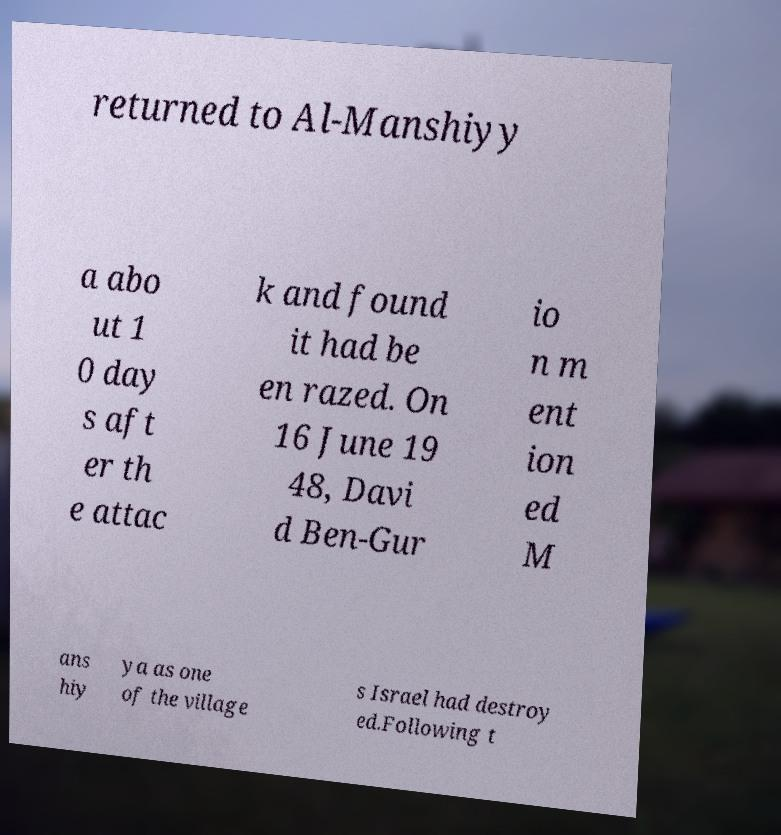Could you assist in decoding the text presented in this image and type it out clearly? returned to Al-Manshiyy a abo ut 1 0 day s aft er th e attac k and found it had be en razed. On 16 June 19 48, Davi d Ben-Gur io n m ent ion ed M ans hiy ya as one of the village s Israel had destroy ed.Following t 